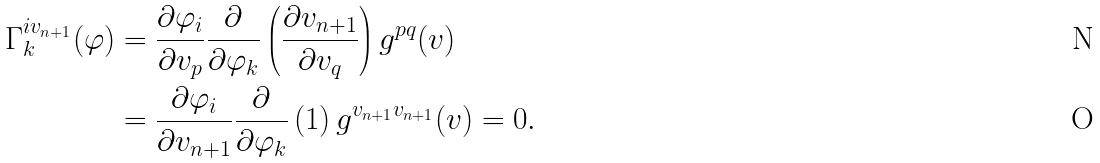Convert formula to latex. <formula><loc_0><loc_0><loc_500><loc_500>\Gamma _ { k } ^ { i v _ { n + 1 } } ( \varphi ) & = \frac { \partial \varphi _ { i } } { \partial v _ { p } } \frac { \partial } { \partial \varphi _ { k } } \left ( \frac { \partial v _ { n + 1 } } { \partial v _ { q } } \right ) g ^ { p q } ( v ) \\ & = \frac { \partial \varphi _ { i } } { \partial v _ { n + 1 } } \frac { \partial } { \partial \varphi _ { k } } \left ( 1 \right ) g ^ { v _ { n + 1 } v _ { n + 1 } } ( v ) = 0 .</formula> 